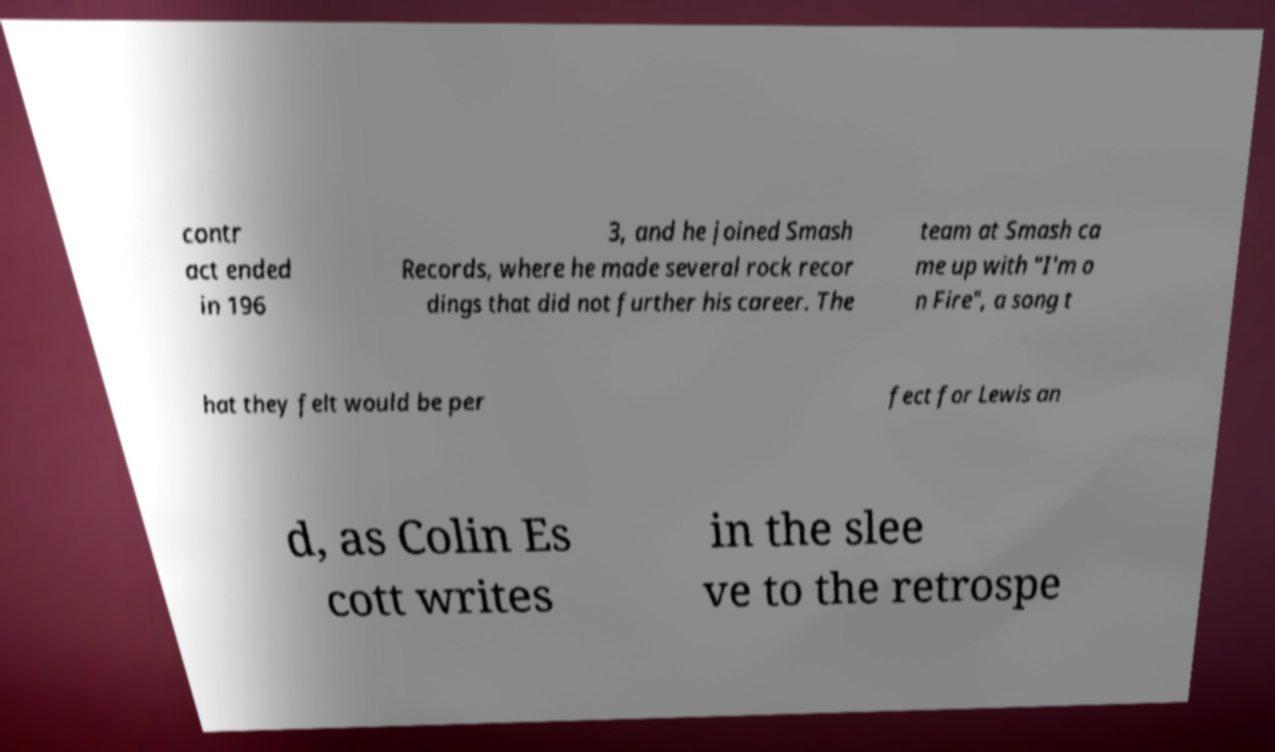Can you accurately transcribe the text from the provided image for me? contr act ended in 196 3, and he joined Smash Records, where he made several rock recor dings that did not further his career. The team at Smash ca me up with "I'm o n Fire", a song t hat they felt would be per fect for Lewis an d, as Colin Es cott writes in the slee ve to the retrospe 